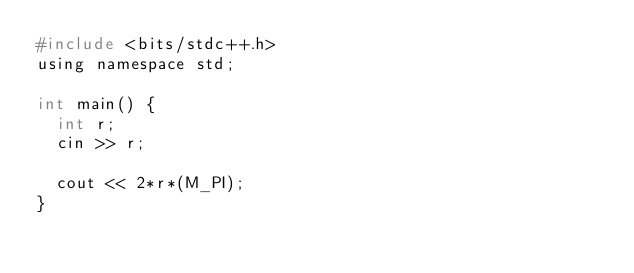Convert code to text. <code><loc_0><loc_0><loc_500><loc_500><_C_>#include <bits/stdc++.h>
using namespace std;

int main() {
  int r;
  cin >> r;

  cout << 2*r*(M_PI);
}
</code> 